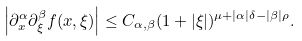Convert formula to latex. <formula><loc_0><loc_0><loc_500><loc_500>\left | \partial _ { x } ^ { \alpha } \partial _ { \xi } ^ { \beta } f ( x , \xi ) \right | \leq C _ { \alpha , \beta } ( 1 + | \xi | ) ^ { \mu + | \alpha | \delta - | \beta | \rho } .</formula> 